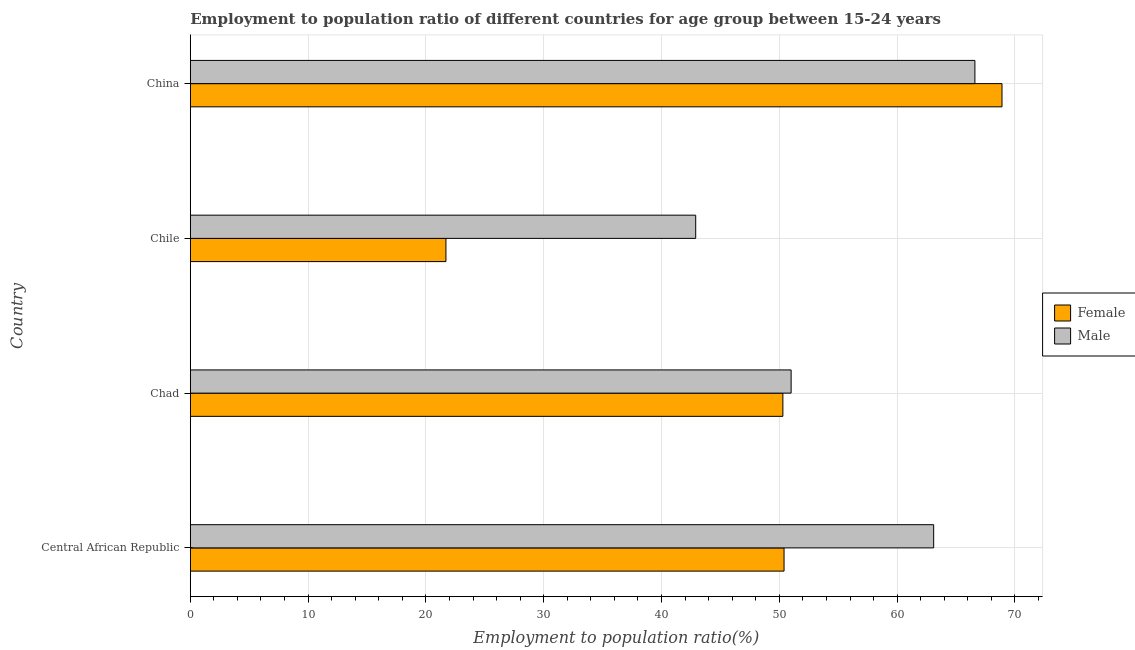Are the number of bars per tick equal to the number of legend labels?
Your response must be concise. Yes. How many bars are there on the 4th tick from the top?
Give a very brief answer. 2. How many bars are there on the 3rd tick from the bottom?
Your response must be concise. 2. What is the label of the 2nd group of bars from the top?
Provide a short and direct response. Chile. What is the employment to population ratio(male) in China?
Your answer should be compact. 66.6. Across all countries, what is the maximum employment to population ratio(male)?
Keep it short and to the point. 66.6. Across all countries, what is the minimum employment to population ratio(male)?
Keep it short and to the point. 42.9. What is the total employment to population ratio(male) in the graph?
Your answer should be compact. 223.6. What is the difference between the employment to population ratio(female) in Chad and that in China?
Offer a very short reply. -18.6. What is the difference between the employment to population ratio(female) in China and the employment to population ratio(male) in Chad?
Provide a succinct answer. 17.9. What is the average employment to population ratio(male) per country?
Make the answer very short. 55.9. In how many countries, is the employment to population ratio(male) greater than 66 %?
Give a very brief answer. 1. What is the ratio of the employment to population ratio(male) in Central African Republic to that in Chile?
Your response must be concise. 1.47. What is the difference between the highest and the lowest employment to population ratio(female)?
Offer a very short reply. 47.2. How many bars are there?
Offer a terse response. 8. Are all the bars in the graph horizontal?
Provide a succinct answer. Yes. How many countries are there in the graph?
Your answer should be compact. 4. What is the difference between two consecutive major ticks on the X-axis?
Your answer should be compact. 10. Does the graph contain any zero values?
Give a very brief answer. No. Does the graph contain grids?
Offer a terse response. Yes. Where does the legend appear in the graph?
Provide a short and direct response. Center right. How many legend labels are there?
Offer a very short reply. 2. What is the title of the graph?
Ensure brevity in your answer.  Employment to population ratio of different countries for age group between 15-24 years. What is the Employment to population ratio(%) in Female in Central African Republic?
Offer a very short reply. 50.4. What is the Employment to population ratio(%) in Male in Central African Republic?
Keep it short and to the point. 63.1. What is the Employment to population ratio(%) in Female in Chad?
Provide a succinct answer. 50.3. What is the Employment to population ratio(%) in Male in Chad?
Offer a very short reply. 51. What is the Employment to population ratio(%) in Female in Chile?
Your answer should be very brief. 21.7. What is the Employment to population ratio(%) of Male in Chile?
Offer a very short reply. 42.9. What is the Employment to population ratio(%) of Female in China?
Your answer should be compact. 68.9. What is the Employment to population ratio(%) in Male in China?
Offer a very short reply. 66.6. Across all countries, what is the maximum Employment to population ratio(%) in Female?
Offer a terse response. 68.9. Across all countries, what is the maximum Employment to population ratio(%) of Male?
Your answer should be compact. 66.6. Across all countries, what is the minimum Employment to population ratio(%) of Female?
Keep it short and to the point. 21.7. Across all countries, what is the minimum Employment to population ratio(%) in Male?
Your answer should be compact. 42.9. What is the total Employment to population ratio(%) in Female in the graph?
Make the answer very short. 191.3. What is the total Employment to population ratio(%) of Male in the graph?
Your response must be concise. 223.6. What is the difference between the Employment to population ratio(%) in Male in Central African Republic and that in Chad?
Offer a very short reply. 12.1. What is the difference between the Employment to population ratio(%) of Female in Central African Republic and that in Chile?
Ensure brevity in your answer.  28.7. What is the difference between the Employment to population ratio(%) of Male in Central African Republic and that in Chile?
Give a very brief answer. 20.2. What is the difference between the Employment to population ratio(%) in Female in Central African Republic and that in China?
Your answer should be very brief. -18.5. What is the difference between the Employment to population ratio(%) in Male in Central African Republic and that in China?
Make the answer very short. -3.5. What is the difference between the Employment to population ratio(%) of Female in Chad and that in Chile?
Your answer should be compact. 28.6. What is the difference between the Employment to population ratio(%) in Female in Chad and that in China?
Give a very brief answer. -18.6. What is the difference between the Employment to population ratio(%) in Male in Chad and that in China?
Give a very brief answer. -15.6. What is the difference between the Employment to population ratio(%) in Female in Chile and that in China?
Give a very brief answer. -47.2. What is the difference between the Employment to population ratio(%) of Male in Chile and that in China?
Your response must be concise. -23.7. What is the difference between the Employment to population ratio(%) of Female in Central African Republic and the Employment to population ratio(%) of Male in China?
Provide a short and direct response. -16.2. What is the difference between the Employment to population ratio(%) of Female in Chad and the Employment to population ratio(%) of Male in Chile?
Offer a terse response. 7.4. What is the difference between the Employment to population ratio(%) in Female in Chad and the Employment to population ratio(%) in Male in China?
Keep it short and to the point. -16.3. What is the difference between the Employment to population ratio(%) of Female in Chile and the Employment to population ratio(%) of Male in China?
Offer a very short reply. -44.9. What is the average Employment to population ratio(%) in Female per country?
Give a very brief answer. 47.83. What is the average Employment to population ratio(%) in Male per country?
Your answer should be compact. 55.9. What is the difference between the Employment to population ratio(%) in Female and Employment to population ratio(%) in Male in Chile?
Make the answer very short. -21.2. What is the ratio of the Employment to population ratio(%) of Male in Central African Republic to that in Chad?
Keep it short and to the point. 1.24. What is the ratio of the Employment to population ratio(%) in Female in Central African Republic to that in Chile?
Provide a short and direct response. 2.32. What is the ratio of the Employment to population ratio(%) of Male in Central African Republic to that in Chile?
Give a very brief answer. 1.47. What is the ratio of the Employment to population ratio(%) of Female in Central African Republic to that in China?
Your answer should be very brief. 0.73. What is the ratio of the Employment to population ratio(%) in Male in Central African Republic to that in China?
Provide a succinct answer. 0.95. What is the ratio of the Employment to population ratio(%) of Female in Chad to that in Chile?
Your response must be concise. 2.32. What is the ratio of the Employment to population ratio(%) in Male in Chad to that in Chile?
Keep it short and to the point. 1.19. What is the ratio of the Employment to population ratio(%) in Female in Chad to that in China?
Offer a very short reply. 0.73. What is the ratio of the Employment to population ratio(%) of Male in Chad to that in China?
Your answer should be very brief. 0.77. What is the ratio of the Employment to population ratio(%) of Female in Chile to that in China?
Make the answer very short. 0.31. What is the ratio of the Employment to population ratio(%) in Male in Chile to that in China?
Keep it short and to the point. 0.64. What is the difference between the highest and the lowest Employment to population ratio(%) in Female?
Your answer should be compact. 47.2. What is the difference between the highest and the lowest Employment to population ratio(%) in Male?
Offer a terse response. 23.7. 